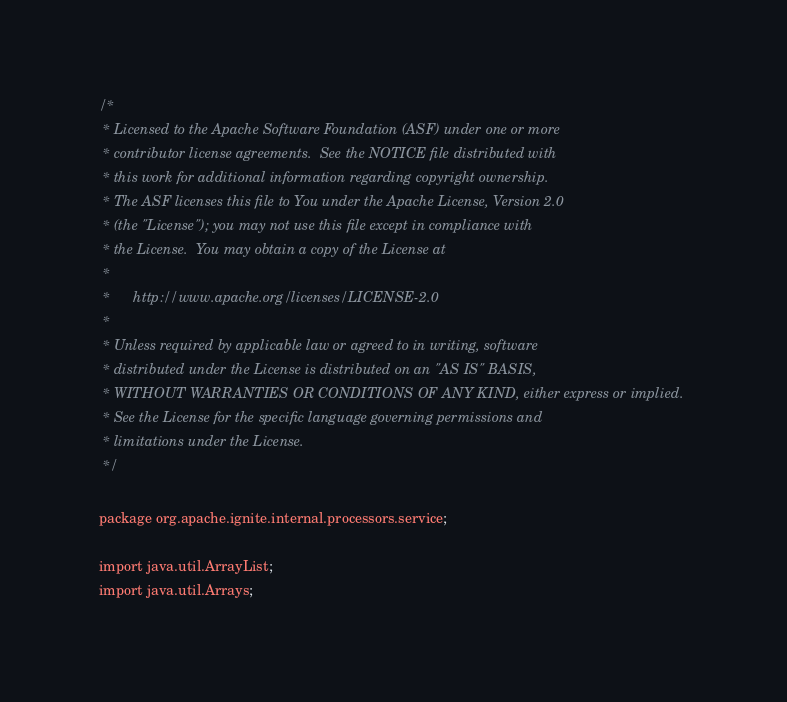<code> <loc_0><loc_0><loc_500><loc_500><_Java_>/*
 * Licensed to the Apache Software Foundation (ASF) under one or more
 * contributor license agreements.  See the NOTICE file distributed with
 * this work for additional information regarding copyright ownership.
 * The ASF licenses this file to You under the Apache License, Version 2.0
 * (the "License"); you may not use this file except in compliance with
 * the License.  You may obtain a copy of the License at
 *
 *      http://www.apache.org/licenses/LICENSE-2.0
 *
 * Unless required by applicable law or agreed to in writing, software
 * distributed under the License is distributed on an "AS IS" BASIS,
 * WITHOUT WARRANTIES OR CONDITIONS OF ANY KIND, either express or implied.
 * See the License for the specific language governing permissions and
 * limitations under the License.
 */

package org.apache.ignite.internal.processors.service;

import java.util.ArrayList;
import java.util.Arrays;</code> 